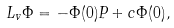<formula> <loc_0><loc_0><loc_500><loc_500>L _ { v } \Phi = - \Phi ( 0 ) P + c \Phi ( 0 ) ,</formula> 